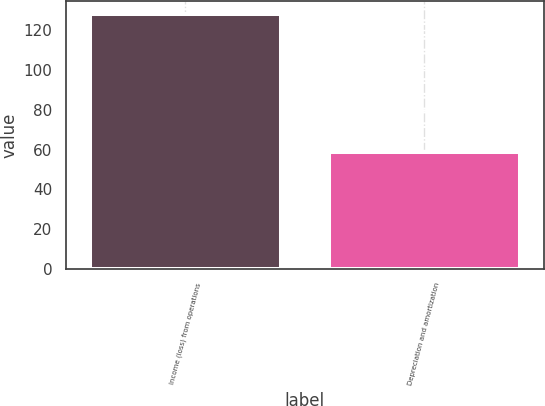Convert chart. <chart><loc_0><loc_0><loc_500><loc_500><bar_chart><fcel>Income (loss) from operations<fcel>Depreciation and amortization<nl><fcel>128.4<fcel>59<nl></chart> 